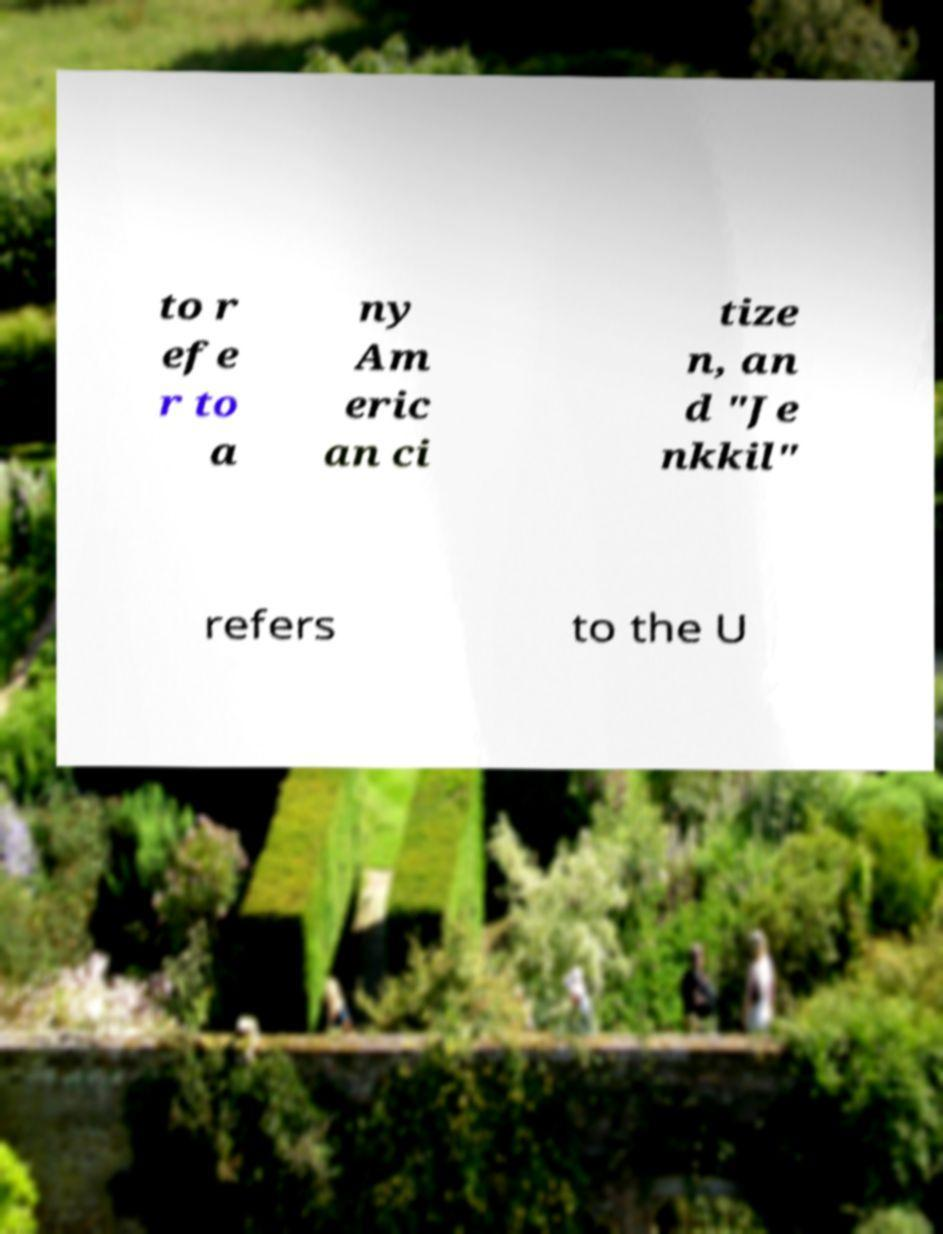Could you extract and type out the text from this image? to r efe r to a ny Am eric an ci tize n, an d "Je nkkil" refers to the U 